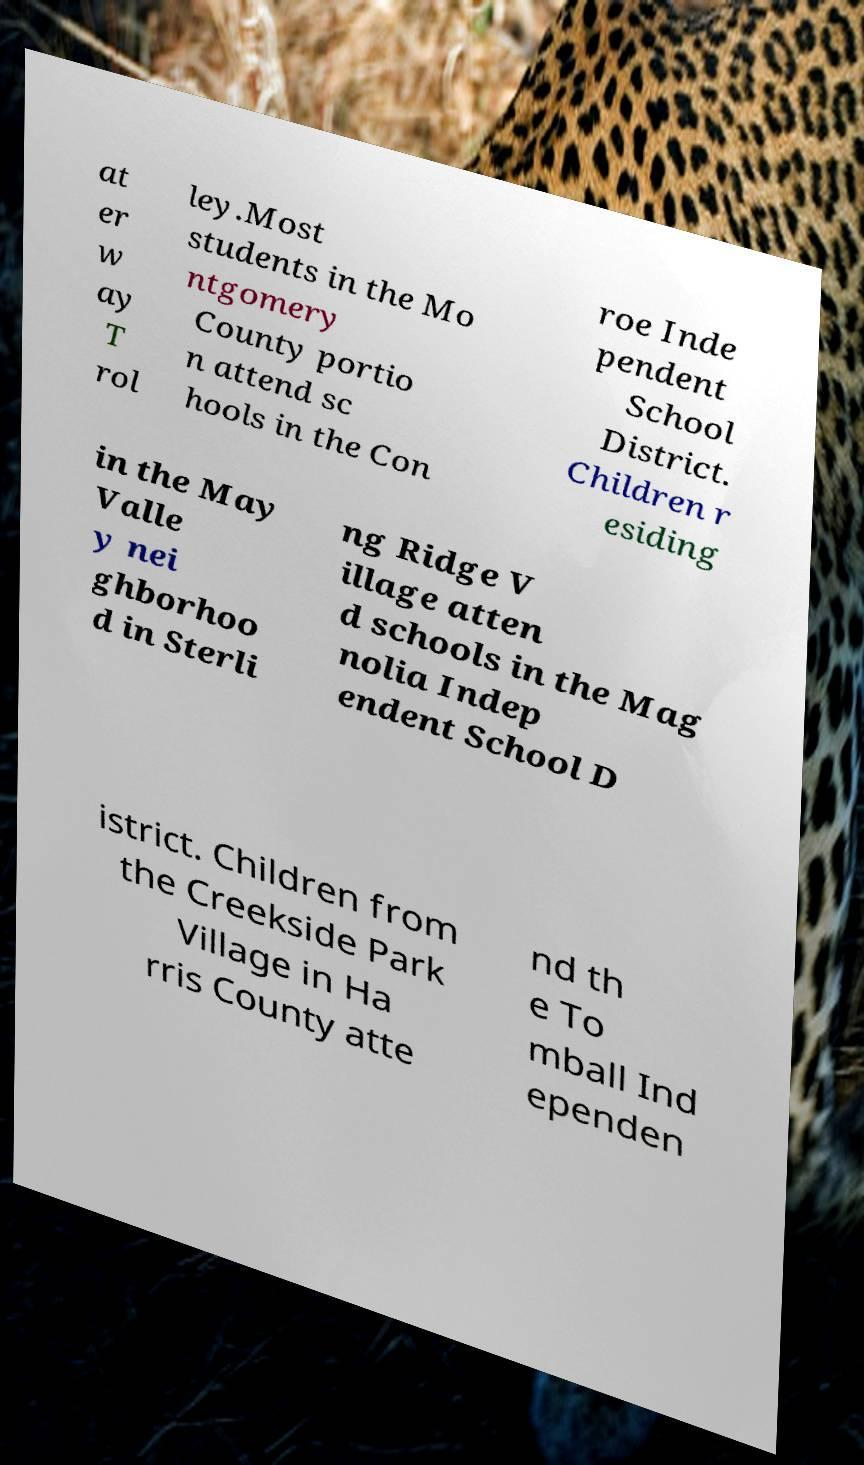For documentation purposes, I need the text within this image transcribed. Could you provide that? at er w ay T rol ley.Most students in the Mo ntgomery County portio n attend sc hools in the Con roe Inde pendent School District. Children r esiding in the May Valle y nei ghborhoo d in Sterli ng Ridge V illage atten d schools in the Mag nolia Indep endent School D istrict. Children from the Creekside Park Village in Ha rris County atte nd th e To mball Ind ependen 